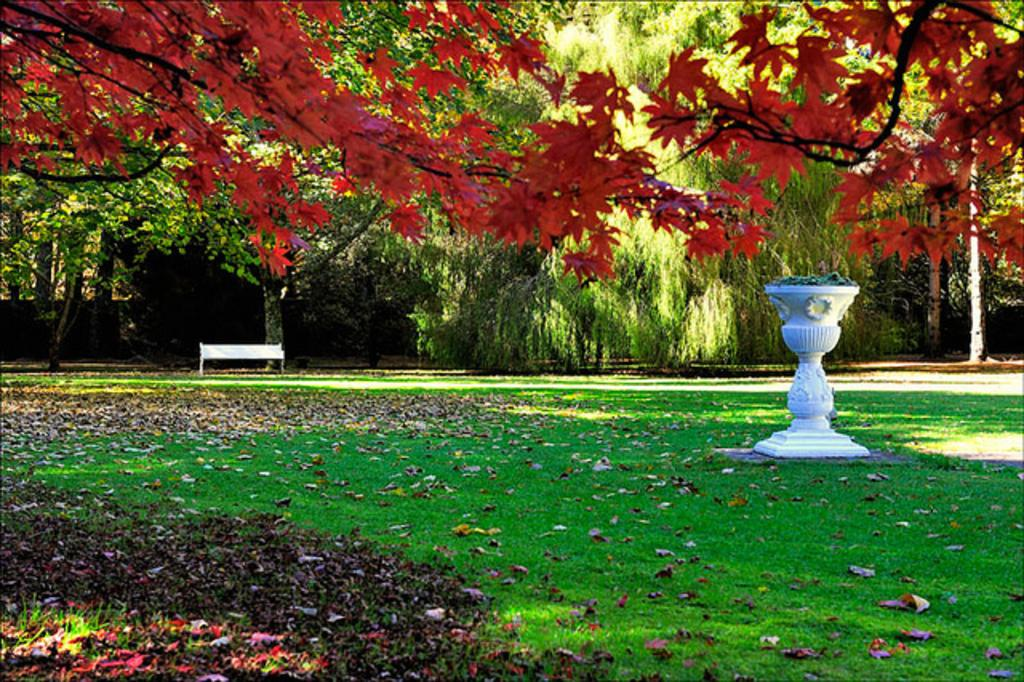What is the main subject of the image? There is a flower stand in the image. What type of vegetation can be seen in the image? There are trees with green color in the image. What type of seating is visible in the background? There is a bench in the background of the image. What type of boot is hanging on the tree in the image? There is no boot present in the image; it features a flower stand, green trees, and a bench. 